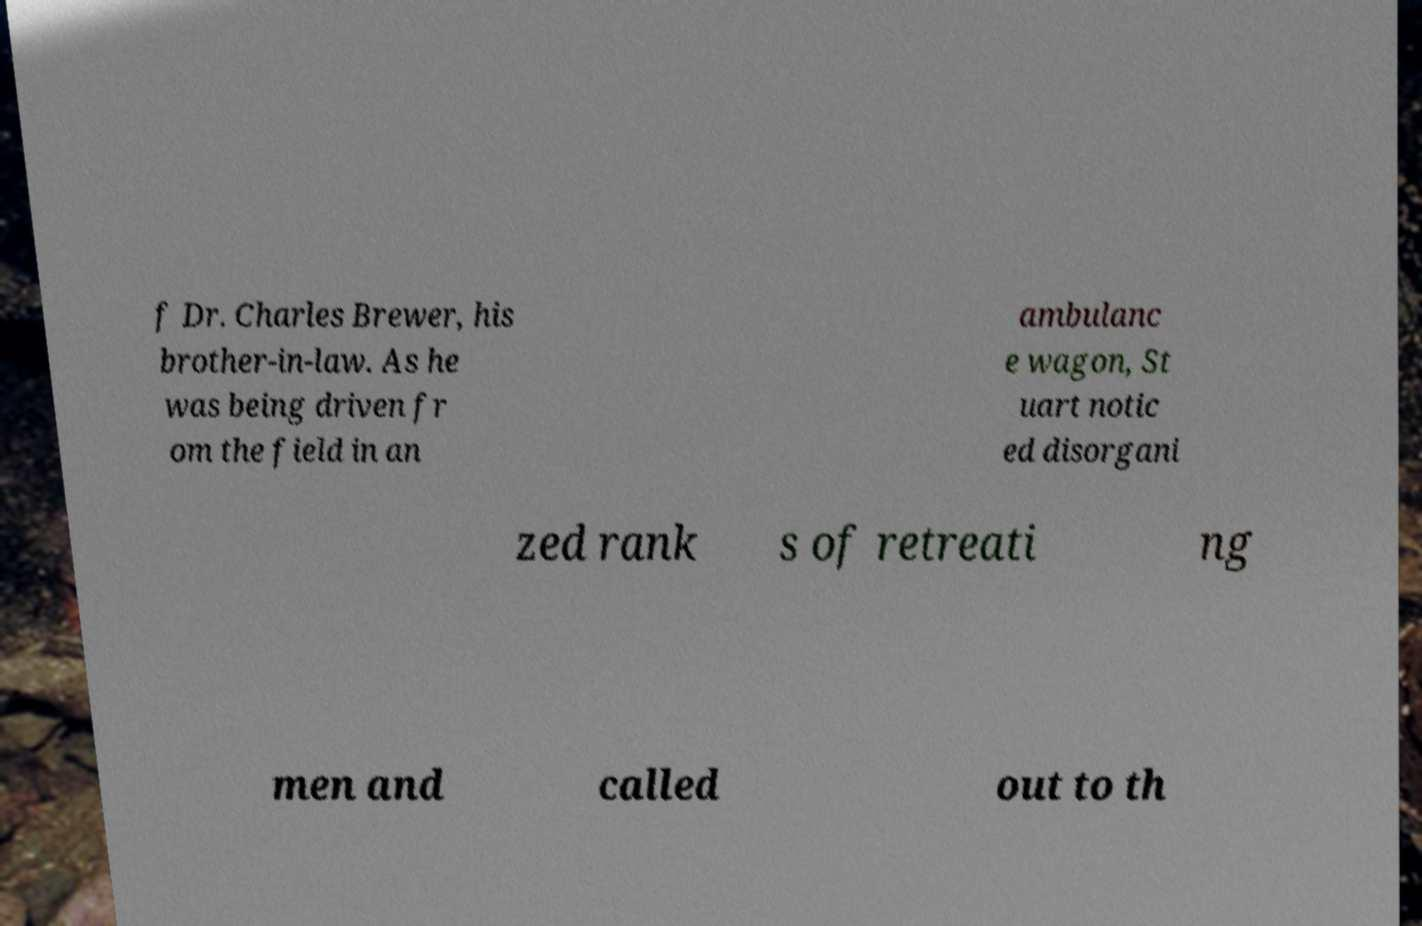Please identify and transcribe the text found in this image. f Dr. Charles Brewer, his brother-in-law. As he was being driven fr om the field in an ambulanc e wagon, St uart notic ed disorgani zed rank s of retreati ng men and called out to th 